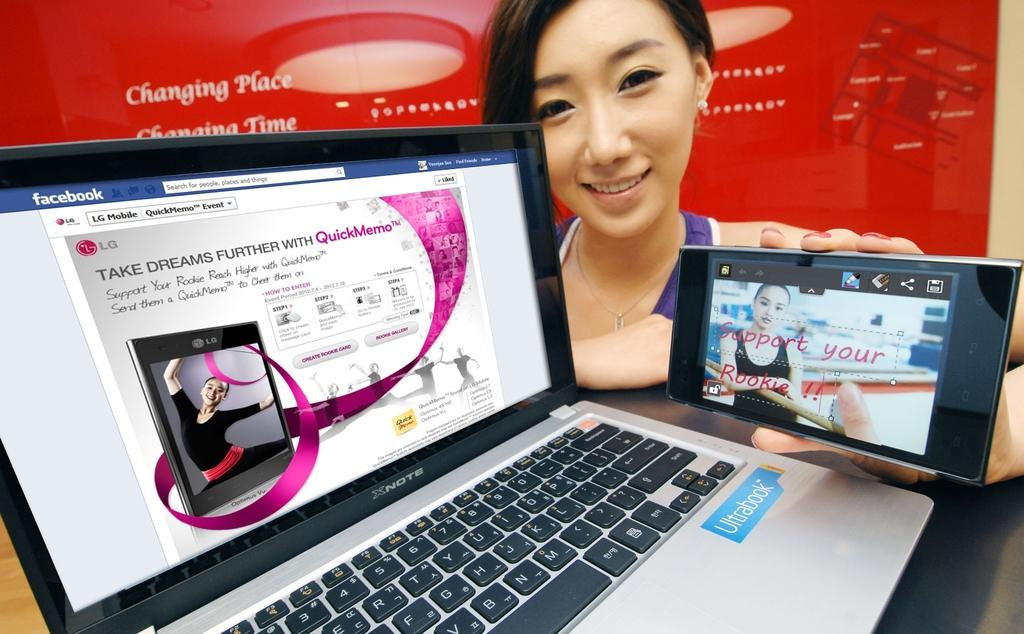<image>
Present a compact description of the photo's key features. A woman poses with an open facebook page on a computer. 